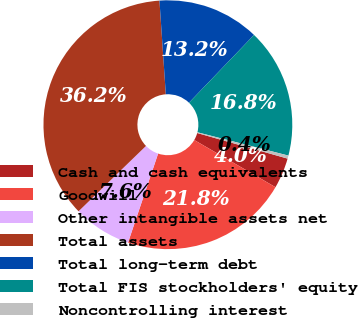Convert chart to OTSL. <chart><loc_0><loc_0><loc_500><loc_500><pie_chart><fcel>Cash and cash equivalents<fcel>Goodwill<fcel>Other intangible assets net<fcel>Total assets<fcel>Total long-term debt<fcel>Total FIS stockholders' equity<fcel>Noncontrolling interest<nl><fcel>3.98%<fcel>21.82%<fcel>7.56%<fcel>36.17%<fcel>13.25%<fcel>16.82%<fcel>0.4%<nl></chart> 